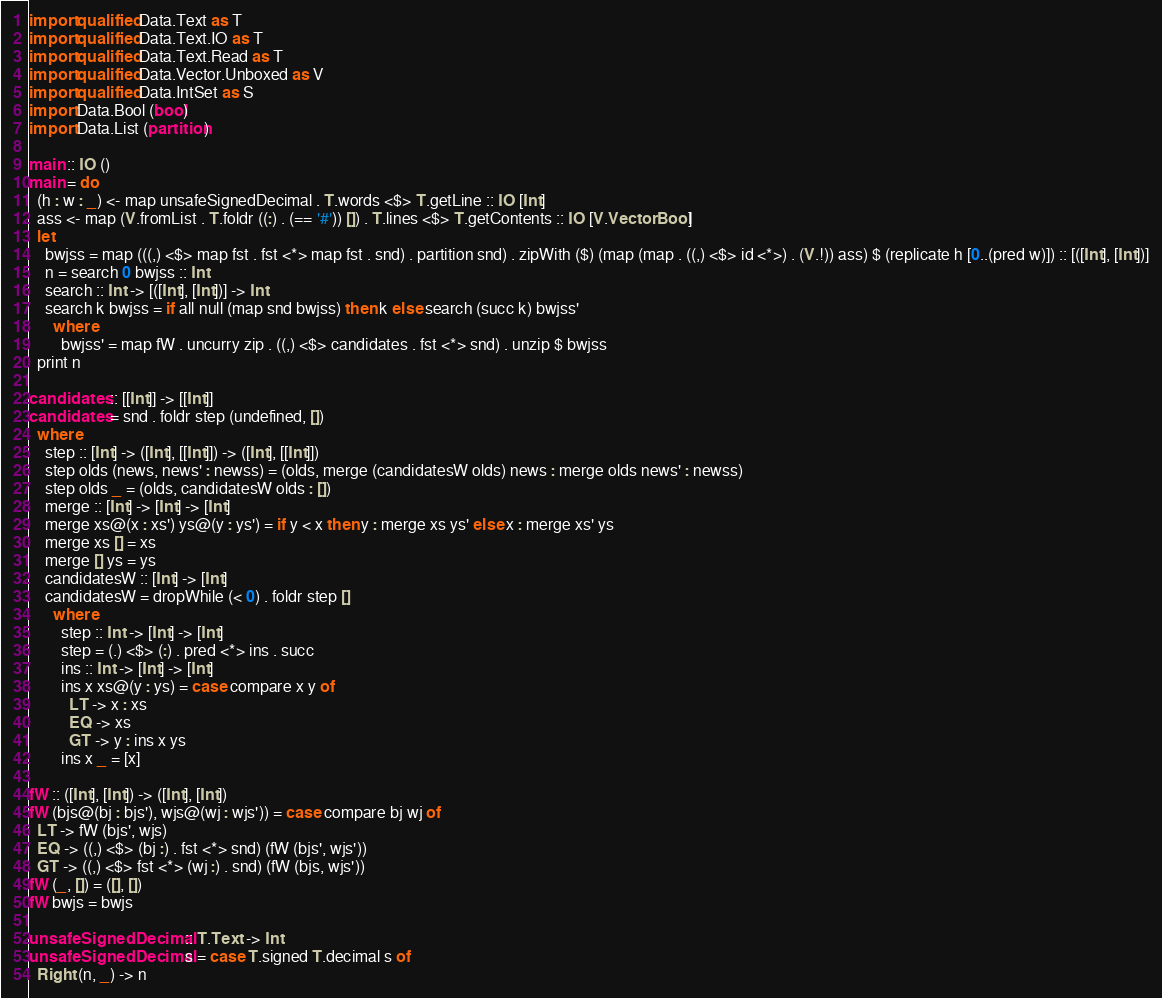Convert code to text. <code><loc_0><loc_0><loc_500><loc_500><_Haskell_>import qualified Data.Text as T
import qualified Data.Text.IO as T
import qualified Data.Text.Read as T
import qualified Data.Vector.Unboxed as V
import qualified Data.IntSet as S
import Data.Bool (bool)
import Data.List (partition)

main :: IO ()
main = do
  (h : w : _) <- map unsafeSignedDecimal . T.words <$> T.getLine :: IO [Int]
  ass <- map (V.fromList . T.foldr ((:) . (== '#')) []) . T.lines <$> T.getContents :: IO [V.Vector Bool]
  let
    bwjss = map (((,) <$> map fst . fst <*> map fst . snd) . partition snd) . zipWith ($) (map (map . ((,) <$> id <*>) . (V.!)) ass) $ (replicate h [0..(pred w)]) :: [([Int], [Int])]
    n = search 0 bwjss :: Int
    search :: Int -> [([Int], [Int])] -> Int
    search k bwjss = if all null (map snd bwjss) then k else search (succ k) bwjss'
      where
        bwjss' = map fW . uncurry zip . ((,) <$> candidates . fst <*> snd) . unzip $ bwjss
  print n

candidates :: [[Int]] -> [[Int]]
candidates = snd . foldr step (undefined, [])
  where
    step :: [Int] -> ([Int], [[Int]]) -> ([Int], [[Int]])
    step olds (news, news' : newss) = (olds, merge (candidatesW olds) news : merge olds news' : newss)
    step olds _ = (olds, candidatesW olds : [])
    merge :: [Int] -> [Int] -> [Int]
    merge xs@(x : xs') ys@(y : ys') = if y < x then y : merge xs ys' else x : merge xs' ys
    merge xs [] = xs
    merge [] ys = ys
    candidatesW :: [Int] -> [Int]
    candidatesW = dropWhile (< 0) . foldr step []
      where
        step :: Int -> [Int] -> [Int]
        step = (.) <$> (:) . pred <*> ins . succ
        ins :: Int -> [Int] -> [Int]
        ins x xs@(y : ys) = case compare x y of
          LT -> x : xs
          EQ -> xs
          GT -> y : ins x ys
        ins x _ = [x]

fW :: ([Int], [Int]) -> ([Int], [Int])
fW (bjs@(bj : bjs'), wjs@(wj : wjs')) = case compare bj wj of
  LT -> fW (bjs', wjs)
  EQ -> ((,) <$> (bj :) . fst <*> snd) (fW (bjs', wjs'))
  GT -> ((,) <$> fst <*> (wj :) . snd) (fW (bjs, wjs'))
fW (_, []) = ([], [])
fW bwjs = bwjs

unsafeSignedDecimal :: T.Text -> Int
unsafeSignedDecimal s = case T.signed T.decimal s of
  Right (n, _) -> n
</code> 